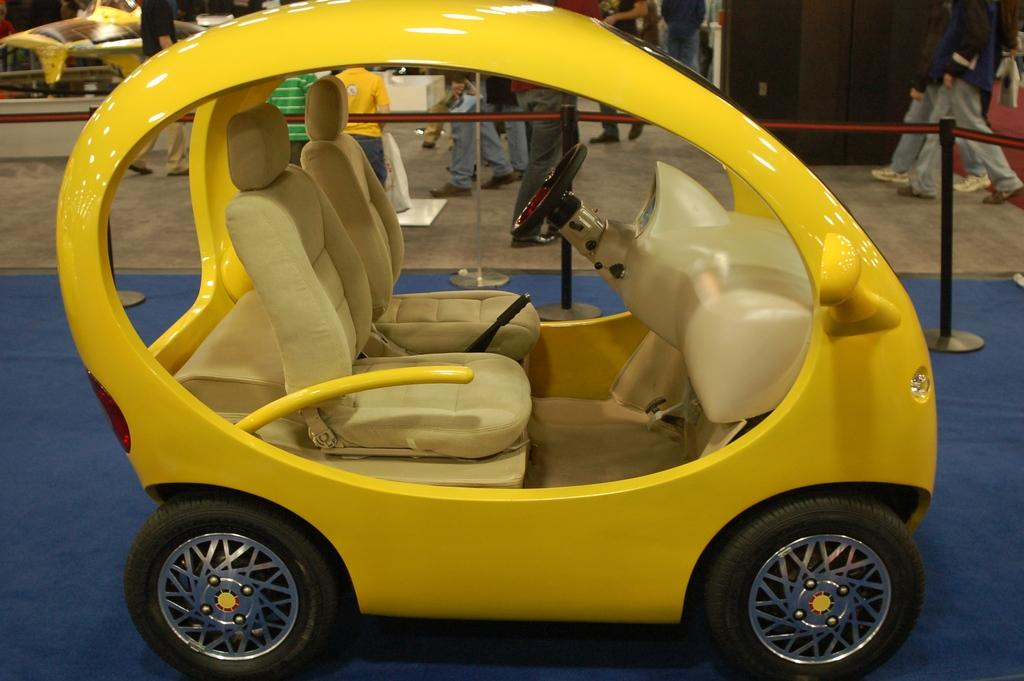What type of object is placed on the carpet in the image? There is a motor vehicle on the carpet. What can be seen in the background of the image? There are poles, persons walking on the floor, and cupboards in the background of the image. What type of whip is being used by the bear to teach the motor vehicle in the image? There are no bears or whips present in the image, and the motor vehicle is not being taught. 